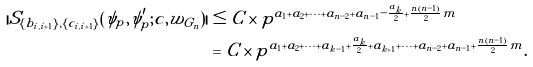<formula> <loc_0><loc_0><loc_500><loc_500>| S _ { \{ b _ { i , i + 1 } \} , \{ c _ { i , i + 1 } \} } ( \psi _ { p } , \psi _ { p } ^ { \prime } ; c , w _ { G _ { n } } ) | & \leq C \times p ^ { a _ { 1 } + a _ { 2 } + \cdots + a _ { n - 2 } + a _ { n - 1 } - \frac { a _ { k } } { 2 } + \frac { n ( n - 1 ) } { 2 } m } \\ & = C \times p ^ { a _ { 1 } + a _ { 2 } + \cdots + a _ { k - 1 } + \frac { a _ { k } } { 2 } + a _ { k + 1 } + \cdots + a _ { n - 2 } + a _ { n - 1 } + \frac { n ( n - 1 ) } { 2 } m } .</formula> 